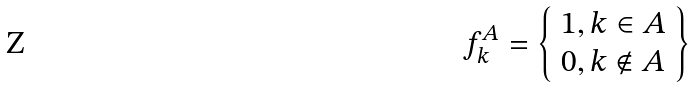<formula> <loc_0><loc_0><loc_500><loc_500>f _ { k } ^ { A } = \left \{ \begin{array} { l } 1 , k \in A \\ 0 , k \notin A \end{array} \right \}</formula> 